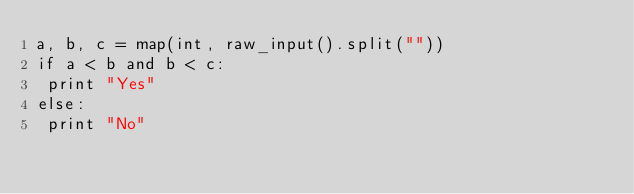Convert code to text. <code><loc_0><loc_0><loc_500><loc_500><_Python_>a, b, c = map(int, raw_input().split(""))
if a < b and b < c:
 print "Yes"
else:
 print "No"</code> 